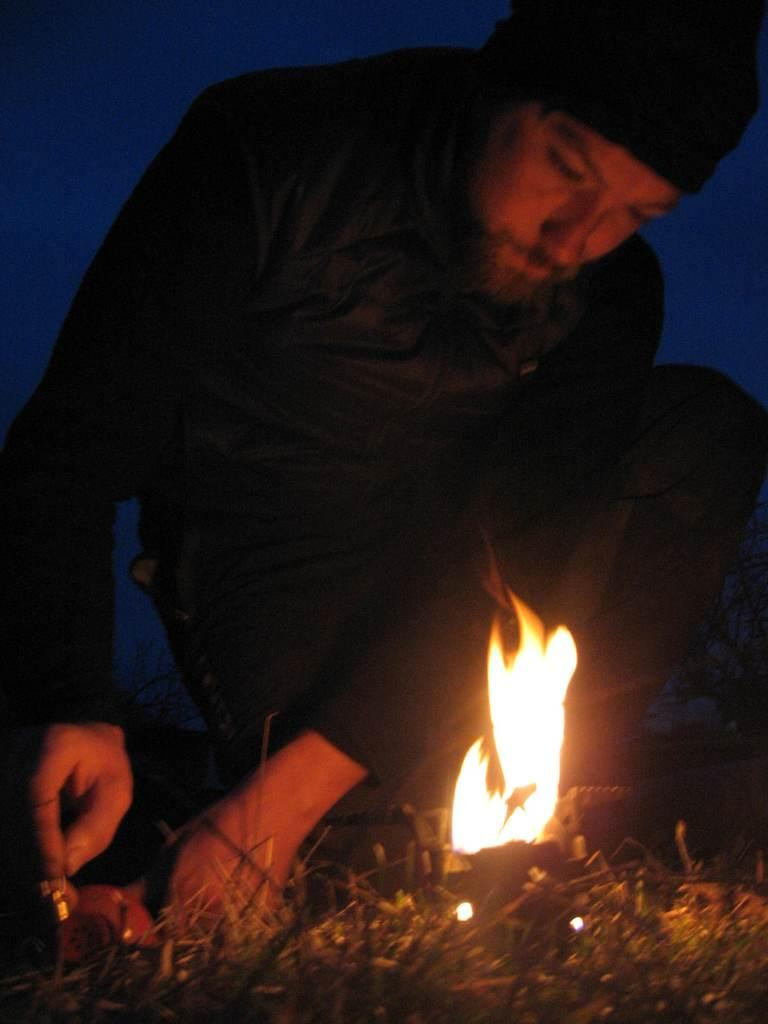Who or what is present in the image? There is a person in the image. What is the person wearing? The person is wearing a dress. What position is the person in? The person is in a squat position. What can be seen in the image besides the person? There is fire visible in the image. What can be observed about the background of the image? The background of the image is dark. What type of cow can be seen in the image? There is no cow present in the image. Who is the authority figure in the image? There is no authority figure mentioned or depicted in the image. 